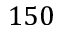Convert formula to latex. <formula><loc_0><loc_0><loc_500><loc_500>1 5 0</formula> 